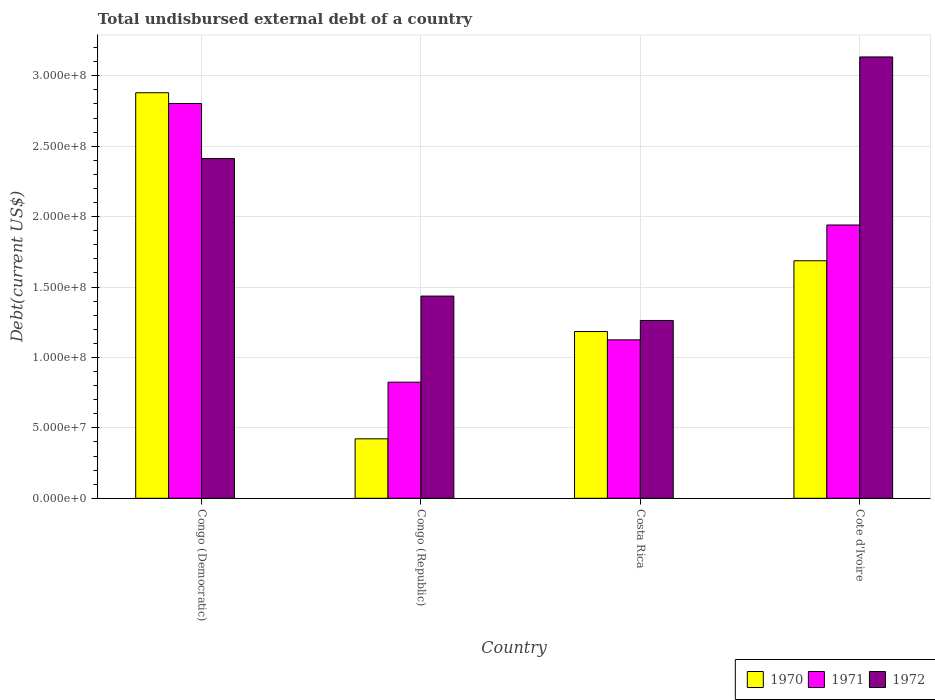How many different coloured bars are there?
Ensure brevity in your answer.  3. How many groups of bars are there?
Give a very brief answer. 4. How many bars are there on the 3rd tick from the left?
Keep it short and to the point. 3. In how many cases, is the number of bars for a given country not equal to the number of legend labels?
Provide a short and direct response. 0. What is the total undisbursed external debt in 1970 in Congo (Democratic)?
Make the answer very short. 2.88e+08. Across all countries, what is the maximum total undisbursed external debt in 1970?
Keep it short and to the point. 2.88e+08. Across all countries, what is the minimum total undisbursed external debt in 1972?
Your response must be concise. 1.26e+08. In which country was the total undisbursed external debt in 1972 maximum?
Your answer should be compact. Cote d'Ivoire. In which country was the total undisbursed external debt in 1971 minimum?
Keep it short and to the point. Congo (Republic). What is the total total undisbursed external debt in 1971 in the graph?
Your answer should be very brief. 6.69e+08. What is the difference between the total undisbursed external debt in 1971 in Congo (Democratic) and that in Costa Rica?
Your answer should be very brief. 1.68e+08. What is the difference between the total undisbursed external debt in 1971 in Congo (Democratic) and the total undisbursed external debt in 1970 in Congo (Republic)?
Ensure brevity in your answer.  2.38e+08. What is the average total undisbursed external debt in 1971 per country?
Your answer should be compact. 1.67e+08. What is the difference between the total undisbursed external debt of/in 1971 and total undisbursed external debt of/in 1970 in Costa Rica?
Your answer should be compact. -5.91e+06. What is the ratio of the total undisbursed external debt in 1970 in Congo (Democratic) to that in Costa Rica?
Offer a very short reply. 2.43. Is the total undisbursed external debt in 1972 in Congo (Democratic) less than that in Cote d'Ivoire?
Keep it short and to the point. Yes. Is the difference between the total undisbursed external debt in 1971 in Congo (Democratic) and Costa Rica greater than the difference between the total undisbursed external debt in 1970 in Congo (Democratic) and Costa Rica?
Provide a succinct answer. No. What is the difference between the highest and the second highest total undisbursed external debt in 1972?
Provide a succinct answer. 7.22e+07. What is the difference between the highest and the lowest total undisbursed external debt in 1971?
Your answer should be very brief. 1.98e+08. Is the sum of the total undisbursed external debt in 1970 in Congo (Republic) and Costa Rica greater than the maximum total undisbursed external debt in 1971 across all countries?
Ensure brevity in your answer.  No. What does the 3rd bar from the left in Congo (Republic) represents?
Your response must be concise. 1972. What does the 1st bar from the right in Costa Rica represents?
Ensure brevity in your answer.  1972. How many bars are there?
Give a very brief answer. 12. Are all the bars in the graph horizontal?
Offer a terse response. No. How many countries are there in the graph?
Your response must be concise. 4. Are the values on the major ticks of Y-axis written in scientific E-notation?
Offer a terse response. Yes. Does the graph contain any zero values?
Offer a terse response. No. Does the graph contain grids?
Give a very brief answer. Yes. How are the legend labels stacked?
Your answer should be compact. Horizontal. What is the title of the graph?
Ensure brevity in your answer.  Total undisbursed external debt of a country. What is the label or title of the X-axis?
Your answer should be very brief. Country. What is the label or title of the Y-axis?
Keep it short and to the point. Debt(current US$). What is the Debt(current US$) of 1970 in Congo (Democratic)?
Provide a short and direct response. 2.88e+08. What is the Debt(current US$) of 1971 in Congo (Democratic)?
Offer a very short reply. 2.80e+08. What is the Debt(current US$) of 1972 in Congo (Democratic)?
Ensure brevity in your answer.  2.41e+08. What is the Debt(current US$) of 1970 in Congo (Republic)?
Make the answer very short. 4.22e+07. What is the Debt(current US$) in 1971 in Congo (Republic)?
Your response must be concise. 8.24e+07. What is the Debt(current US$) of 1972 in Congo (Republic)?
Give a very brief answer. 1.44e+08. What is the Debt(current US$) in 1970 in Costa Rica?
Make the answer very short. 1.18e+08. What is the Debt(current US$) of 1971 in Costa Rica?
Make the answer very short. 1.12e+08. What is the Debt(current US$) of 1972 in Costa Rica?
Your answer should be compact. 1.26e+08. What is the Debt(current US$) in 1970 in Cote d'Ivoire?
Keep it short and to the point. 1.69e+08. What is the Debt(current US$) of 1971 in Cote d'Ivoire?
Keep it short and to the point. 1.94e+08. What is the Debt(current US$) in 1972 in Cote d'Ivoire?
Give a very brief answer. 3.13e+08. Across all countries, what is the maximum Debt(current US$) of 1970?
Provide a succinct answer. 2.88e+08. Across all countries, what is the maximum Debt(current US$) in 1971?
Ensure brevity in your answer.  2.80e+08. Across all countries, what is the maximum Debt(current US$) in 1972?
Give a very brief answer. 3.13e+08. Across all countries, what is the minimum Debt(current US$) of 1970?
Ensure brevity in your answer.  4.22e+07. Across all countries, what is the minimum Debt(current US$) of 1971?
Offer a very short reply. 8.24e+07. Across all countries, what is the minimum Debt(current US$) in 1972?
Make the answer very short. 1.26e+08. What is the total Debt(current US$) in 1970 in the graph?
Make the answer very short. 6.17e+08. What is the total Debt(current US$) of 1971 in the graph?
Your answer should be very brief. 6.69e+08. What is the total Debt(current US$) in 1972 in the graph?
Make the answer very short. 8.24e+08. What is the difference between the Debt(current US$) in 1970 in Congo (Democratic) and that in Congo (Republic)?
Your answer should be compact. 2.46e+08. What is the difference between the Debt(current US$) of 1971 in Congo (Democratic) and that in Congo (Republic)?
Provide a short and direct response. 1.98e+08. What is the difference between the Debt(current US$) of 1972 in Congo (Democratic) and that in Congo (Republic)?
Provide a short and direct response. 9.76e+07. What is the difference between the Debt(current US$) in 1970 in Congo (Democratic) and that in Costa Rica?
Offer a very short reply. 1.70e+08. What is the difference between the Debt(current US$) of 1971 in Congo (Democratic) and that in Costa Rica?
Give a very brief answer. 1.68e+08. What is the difference between the Debt(current US$) in 1972 in Congo (Democratic) and that in Costa Rica?
Offer a very short reply. 1.15e+08. What is the difference between the Debt(current US$) in 1970 in Congo (Democratic) and that in Cote d'Ivoire?
Your response must be concise. 1.19e+08. What is the difference between the Debt(current US$) in 1971 in Congo (Democratic) and that in Cote d'Ivoire?
Ensure brevity in your answer.  8.63e+07. What is the difference between the Debt(current US$) of 1972 in Congo (Democratic) and that in Cote d'Ivoire?
Your answer should be very brief. -7.22e+07. What is the difference between the Debt(current US$) of 1970 in Congo (Republic) and that in Costa Rica?
Give a very brief answer. -7.62e+07. What is the difference between the Debt(current US$) of 1971 in Congo (Republic) and that in Costa Rica?
Your answer should be very brief. -3.00e+07. What is the difference between the Debt(current US$) of 1972 in Congo (Republic) and that in Costa Rica?
Provide a succinct answer. 1.73e+07. What is the difference between the Debt(current US$) in 1970 in Congo (Republic) and that in Cote d'Ivoire?
Make the answer very short. -1.26e+08. What is the difference between the Debt(current US$) in 1971 in Congo (Republic) and that in Cote d'Ivoire?
Provide a short and direct response. -1.12e+08. What is the difference between the Debt(current US$) of 1972 in Congo (Republic) and that in Cote d'Ivoire?
Provide a succinct answer. -1.70e+08. What is the difference between the Debt(current US$) in 1970 in Costa Rica and that in Cote d'Ivoire?
Provide a short and direct response. -5.03e+07. What is the difference between the Debt(current US$) in 1971 in Costa Rica and that in Cote d'Ivoire?
Keep it short and to the point. -8.16e+07. What is the difference between the Debt(current US$) in 1972 in Costa Rica and that in Cote d'Ivoire?
Provide a short and direct response. -1.87e+08. What is the difference between the Debt(current US$) of 1970 in Congo (Democratic) and the Debt(current US$) of 1971 in Congo (Republic)?
Your answer should be very brief. 2.06e+08. What is the difference between the Debt(current US$) of 1970 in Congo (Democratic) and the Debt(current US$) of 1972 in Congo (Republic)?
Provide a short and direct response. 1.44e+08. What is the difference between the Debt(current US$) of 1971 in Congo (Democratic) and the Debt(current US$) of 1972 in Congo (Republic)?
Provide a succinct answer. 1.37e+08. What is the difference between the Debt(current US$) of 1970 in Congo (Democratic) and the Debt(current US$) of 1971 in Costa Rica?
Provide a succinct answer. 1.75e+08. What is the difference between the Debt(current US$) in 1970 in Congo (Democratic) and the Debt(current US$) in 1972 in Costa Rica?
Provide a short and direct response. 1.62e+08. What is the difference between the Debt(current US$) in 1971 in Congo (Democratic) and the Debt(current US$) in 1972 in Costa Rica?
Your answer should be very brief. 1.54e+08. What is the difference between the Debt(current US$) of 1970 in Congo (Democratic) and the Debt(current US$) of 1971 in Cote d'Ivoire?
Offer a very short reply. 9.39e+07. What is the difference between the Debt(current US$) in 1970 in Congo (Democratic) and the Debt(current US$) in 1972 in Cote d'Ivoire?
Give a very brief answer. -2.54e+07. What is the difference between the Debt(current US$) of 1971 in Congo (Democratic) and the Debt(current US$) of 1972 in Cote d'Ivoire?
Provide a short and direct response. -3.30e+07. What is the difference between the Debt(current US$) of 1970 in Congo (Republic) and the Debt(current US$) of 1971 in Costa Rica?
Your response must be concise. -7.03e+07. What is the difference between the Debt(current US$) of 1970 in Congo (Republic) and the Debt(current US$) of 1972 in Costa Rica?
Make the answer very short. -8.41e+07. What is the difference between the Debt(current US$) in 1971 in Congo (Republic) and the Debt(current US$) in 1972 in Costa Rica?
Offer a very short reply. -4.38e+07. What is the difference between the Debt(current US$) of 1970 in Congo (Republic) and the Debt(current US$) of 1971 in Cote d'Ivoire?
Provide a short and direct response. -1.52e+08. What is the difference between the Debt(current US$) in 1970 in Congo (Republic) and the Debt(current US$) in 1972 in Cote d'Ivoire?
Ensure brevity in your answer.  -2.71e+08. What is the difference between the Debt(current US$) in 1971 in Congo (Republic) and the Debt(current US$) in 1972 in Cote d'Ivoire?
Offer a very short reply. -2.31e+08. What is the difference between the Debt(current US$) of 1970 in Costa Rica and the Debt(current US$) of 1971 in Cote d'Ivoire?
Make the answer very short. -7.57e+07. What is the difference between the Debt(current US$) of 1970 in Costa Rica and the Debt(current US$) of 1972 in Cote d'Ivoire?
Ensure brevity in your answer.  -1.95e+08. What is the difference between the Debt(current US$) in 1971 in Costa Rica and the Debt(current US$) in 1972 in Cote d'Ivoire?
Ensure brevity in your answer.  -2.01e+08. What is the average Debt(current US$) of 1970 per country?
Offer a terse response. 1.54e+08. What is the average Debt(current US$) of 1971 per country?
Your answer should be very brief. 1.67e+08. What is the average Debt(current US$) in 1972 per country?
Your response must be concise. 2.06e+08. What is the difference between the Debt(current US$) in 1970 and Debt(current US$) in 1971 in Congo (Democratic)?
Keep it short and to the point. 7.62e+06. What is the difference between the Debt(current US$) in 1970 and Debt(current US$) in 1972 in Congo (Democratic)?
Offer a terse response. 4.67e+07. What is the difference between the Debt(current US$) in 1971 and Debt(current US$) in 1972 in Congo (Democratic)?
Keep it short and to the point. 3.91e+07. What is the difference between the Debt(current US$) in 1970 and Debt(current US$) in 1971 in Congo (Republic)?
Your response must be concise. -4.02e+07. What is the difference between the Debt(current US$) in 1970 and Debt(current US$) in 1972 in Congo (Republic)?
Your answer should be compact. -1.01e+08. What is the difference between the Debt(current US$) in 1971 and Debt(current US$) in 1972 in Congo (Republic)?
Give a very brief answer. -6.11e+07. What is the difference between the Debt(current US$) in 1970 and Debt(current US$) in 1971 in Costa Rica?
Offer a terse response. 5.91e+06. What is the difference between the Debt(current US$) of 1970 and Debt(current US$) of 1972 in Costa Rica?
Ensure brevity in your answer.  -7.86e+06. What is the difference between the Debt(current US$) of 1971 and Debt(current US$) of 1972 in Costa Rica?
Provide a short and direct response. -1.38e+07. What is the difference between the Debt(current US$) of 1970 and Debt(current US$) of 1971 in Cote d'Ivoire?
Keep it short and to the point. -2.54e+07. What is the difference between the Debt(current US$) in 1970 and Debt(current US$) in 1972 in Cote d'Ivoire?
Your response must be concise. -1.45e+08. What is the difference between the Debt(current US$) of 1971 and Debt(current US$) of 1972 in Cote d'Ivoire?
Give a very brief answer. -1.19e+08. What is the ratio of the Debt(current US$) of 1970 in Congo (Democratic) to that in Congo (Republic)?
Give a very brief answer. 6.82. What is the ratio of the Debt(current US$) in 1971 in Congo (Democratic) to that in Congo (Republic)?
Offer a very short reply. 3.4. What is the ratio of the Debt(current US$) in 1972 in Congo (Democratic) to that in Congo (Republic)?
Provide a short and direct response. 1.68. What is the ratio of the Debt(current US$) of 1970 in Congo (Democratic) to that in Costa Rica?
Keep it short and to the point. 2.43. What is the ratio of the Debt(current US$) of 1971 in Congo (Democratic) to that in Costa Rica?
Offer a very short reply. 2.49. What is the ratio of the Debt(current US$) in 1972 in Congo (Democratic) to that in Costa Rica?
Offer a very short reply. 1.91. What is the ratio of the Debt(current US$) in 1970 in Congo (Democratic) to that in Cote d'Ivoire?
Provide a short and direct response. 1.71. What is the ratio of the Debt(current US$) of 1971 in Congo (Democratic) to that in Cote d'Ivoire?
Provide a short and direct response. 1.44. What is the ratio of the Debt(current US$) of 1972 in Congo (Democratic) to that in Cote d'Ivoire?
Your response must be concise. 0.77. What is the ratio of the Debt(current US$) in 1970 in Congo (Republic) to that in Costa Rica?
Your answer should be compact. 0.36. What is the ratio of the Debt(current US$) in 1971 in Congo (Republic) to that in Costa Rica?
Make the answer very short. 0.73. What is the ratio of the Debt(current US$) in 1972 in Congo (Republic) to that in Costa Rica?
Give a very brief answer. 1.14. What is the ratio of the Debt(current US$) in 1970 in Congo (Republic) to that in Cote d'Ivoire?
Give a very brief answer. 0.25. What is the ratio of the Debt(current US$) of 1971 in Congo (Republic) to that in Cote d'Ivoire?
Offer a very short reply. 0.42. What is the ratio of the Debt(current US$) in 1972 in Congo (Republic) to that in Cote d'Ivoire?
Keep it short and to the point. 0.46. What is the ratio of the Debt(current US$) of 1970 in Costa Rica to that in Cote d'Ivoire?
Ensure brevity in your answer.  0.7. What is the ratio of the Debt(current US$) of 1971 in Costa Rica to that in Cote d'Ivoire?
Provide a succinct answer. 0.58. What is the ratio of the Debt(current US$) of 1972 in Costa Rica to that in Cote d'Ivoire?
Your answer should be compact. 0.4. What is the difference between the highest and the second highest Debt(current US$) of 1970?
Give a very brief answer. 1.19e+08. What is the difference between the highest and the second highest Debt(current US$) of 1971?
Offer a very short reply. 8.63e+07. What is the difference between the highest and the second highest Debt(current US$) of 1972?
Offer a terse response. 7.22e+07. What is the difference between the highest and the lowest Debt(current US$) in 1970?
Ensure brevity in your answer.  2.46e+08. What is the difference between the highest and the lowest Debt(current US$) of 1971?
Give a very brief answer. 1.98e+08. What is the difference between the highest and the lowest Debt(current US$) of 1972?
Provide a succinct answer. 1.87e+08. 